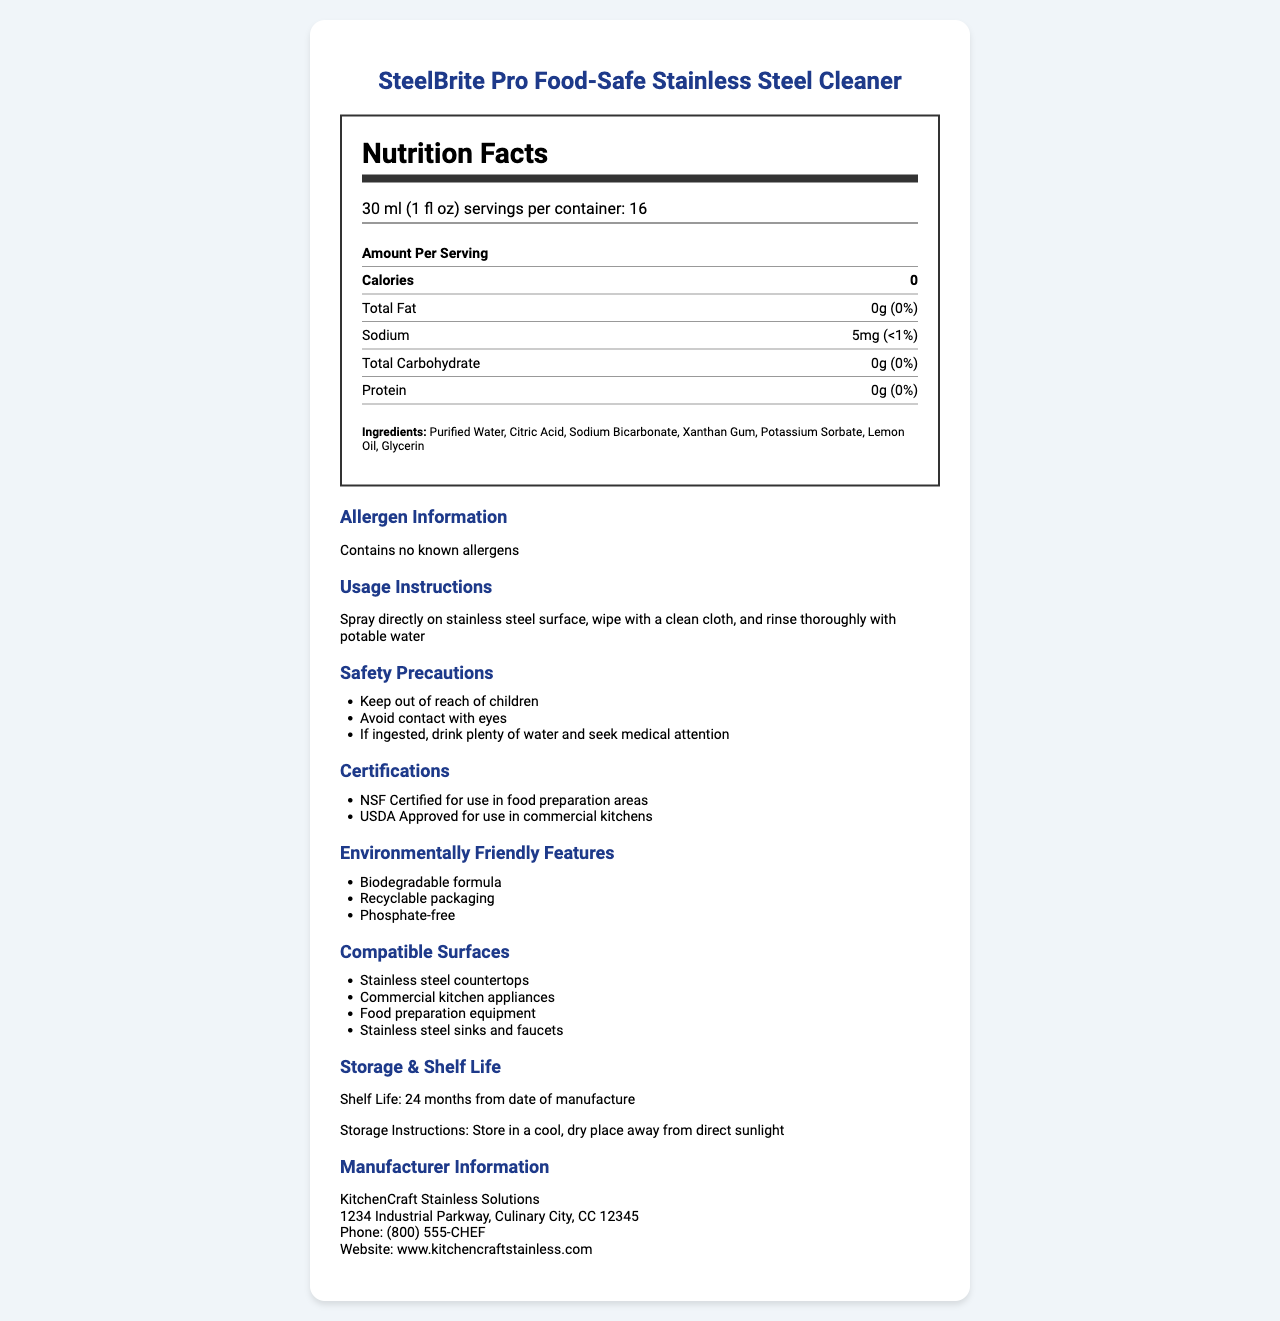what is the serving size for the SteelBrite Pro Food-Safe Stainless Steel Cleaner? The serving size is explicitly stated in the document under the "serving size" section in the nutrition label.
Answer: 30 ml (1 fl oz) what are the primary ingredients of the cleaner? The ingredients are listed in the document under the "Ingredients" section in the nutrition label.
Answer: Purified Water, Citric Acid, Sodium Bicarbonate, Xanthan Gum, Potassium Sorbate, Lemon Oil, Glycerin how many calories are there per serving of SteelBrite Pro? The calorie count is specified in the "Nutrition Facts" section of the document.
Answer: 0 does the product contain any known allergens? The document states explicitly "Contains no known allergens" under the allergen information section.
Answer: No What is one of the safety precautions mentioned for this cleaner? This safety precaution is listed under the "Safety Precautions" section in the additional information part of the document.
Answer: Keep out of reach of children Which authority has certified the product for use in food preparation areas? A. FDA B. USDA C. NSF D. EPA The document mentions that the product is "NSF Certified for use in food preparation areas" under the certifications section.
Answer: C What is the correct course of action if the cleaner is ingested? 1. Seek medical attention immediately 2. Drink plenty of water and seek medical attention 3. Induce vomiting 4. Take an antacid The safety precautions in the document state "If ingested, drink plenty of water and seek medical attention".
Answer: 2 Is SteelBrite Pro's formula biodegradable? The document lists "Biodegradable formula" under the environmentally friendly features section.
Answer: Yes Summarize the main uses and features of the SteelBrite Pro Food-Safe Stainless Steel Cleaner. This summary captures the key features and uses of the product, based on the comprehensive content described throughout the document.
Answer: SteelBrite Pro Food-Safe Stainless Steel Cleaner is a versatile and safe cleaning solution designed for stainless steel surfaces in commercial kitchens. It contains food-safe ingredients, is environmentally friendly, and holds certifications from NSF and USDA. It is suitable for use on stainless steel countertops, kitchen appliances, food preparation equipment, and more. The product has a shelf life of 24 months, requires proper storage, and has clear usage and safety instructions. What is the total carbohydrate content per serving? The total carbohydrate content is listed as 0g in the nutrition facts section of the document.
Answer: 0g How many servings are there per container of SteelBrite Pro? The serving size and servings per container information are provided at the top of the nutrition label.
Answer: 16 Is the packaging of SteelBrite Pro recyclable? The document mentions "Recyclable packaging" under the environmentally friendly features section.
Answer: Yes What is the total sodium content contributed by one serving of the product in percentage? The sodium content is listed both in mg and as a percentage of the daily value, which is explicitly mentioned as "<1%" in the nutrition facts section.
Answer: <1% What is the address of the manufacturer KitchenCraft Stainless Solutions? The manufacturer's address is provided in the manufacturer information section.
Answer: 1234 Industrial Parkway, Culinary City, CC 12345 What is the exact chemical formula of Citric Acid? The document lists citric acid as an ingredient, but it does not provide its chemical formula. Therefore, the information is not available in the visual document provided.
Answer: Not enough information 